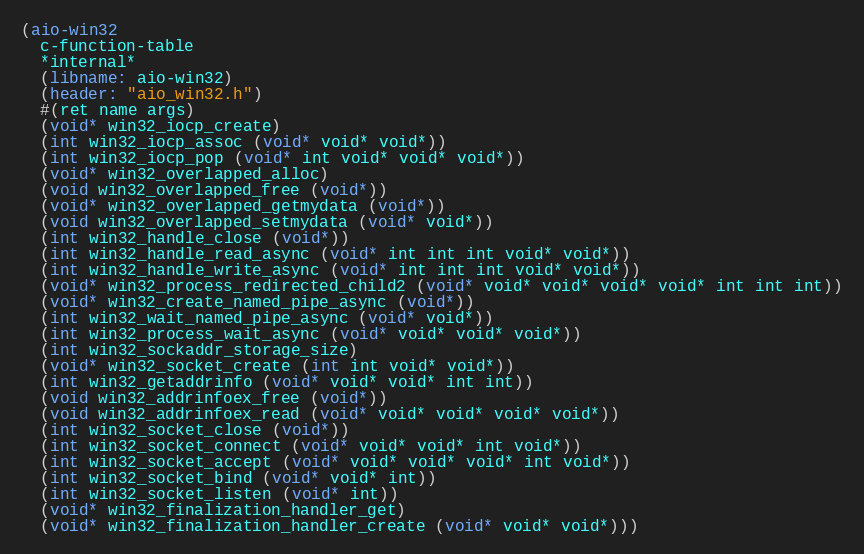Convert code to text. <code><loc_0><loc_0><loc_500><loc_500><_Scheme_>(aio-win32
  c-function-table
  *internal*
  (libname: aio-win32)
  (header: "aio_win32.h")
  #(ret name args)
  (void* win32_iocp_create)
  (int win32_iocp_assoc (void* void* void*))
  (int win32_iocp_pop (void* int void* void* void*))
  (void* win32_overlapped_alloc)
  (void win32_overlapped_free (void*))
  (void* win32_overlapped_getmydata (void*))
  (void win32_overlapped_setmydata (void* void*))
  (int win32_handle_close (void*))
  (int win32_handle_read_async (void* int int int void* void*))
  (int win32_handle_write_async (void* int int int void* void*))
  (void* win32_process_redirected_child2 (void* void* void* void* void* int int int))
  (void* win32_create_named_pipe_async (void*))
  (int win32_wait_named_pipe_async (void* void*))
  (int win32_process_wait_async (void* void* void* void*))
  (int win32_sockaddr_storage_size)
  (void* win32_socket_create (int int void* void*))
  (int win32_getaddrinfo (void* void* void* int int))
  (void win32_addrinfoex_free (void*))
  (void win32_addrinfoex_read (void* void* void* void* void*))
  (int win32_socket_close (void*))
  (int win32_socket_connect (void* void* void* int void*))
  (int win32_socket_accept (void* void* void* void* int void*))
  (int win32_socket_bind (void* void* int))
  (int win32_socket_listen (void* int))
  (void* win32_finalization_handler_get)
  (void* win32_finalization_handler_create (void* void* void*)))
</code> 